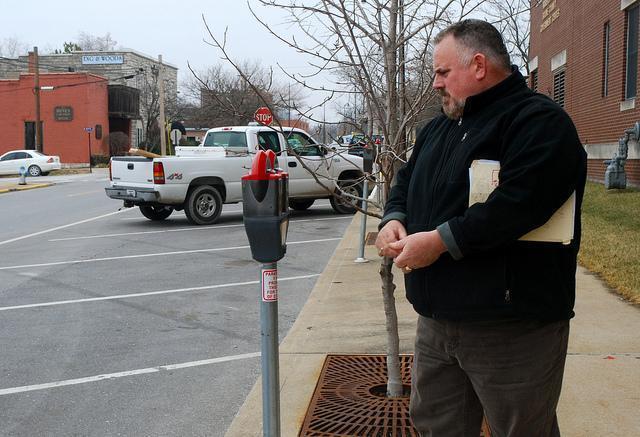How many bowls are there?
Give a very brief answer. 0. 